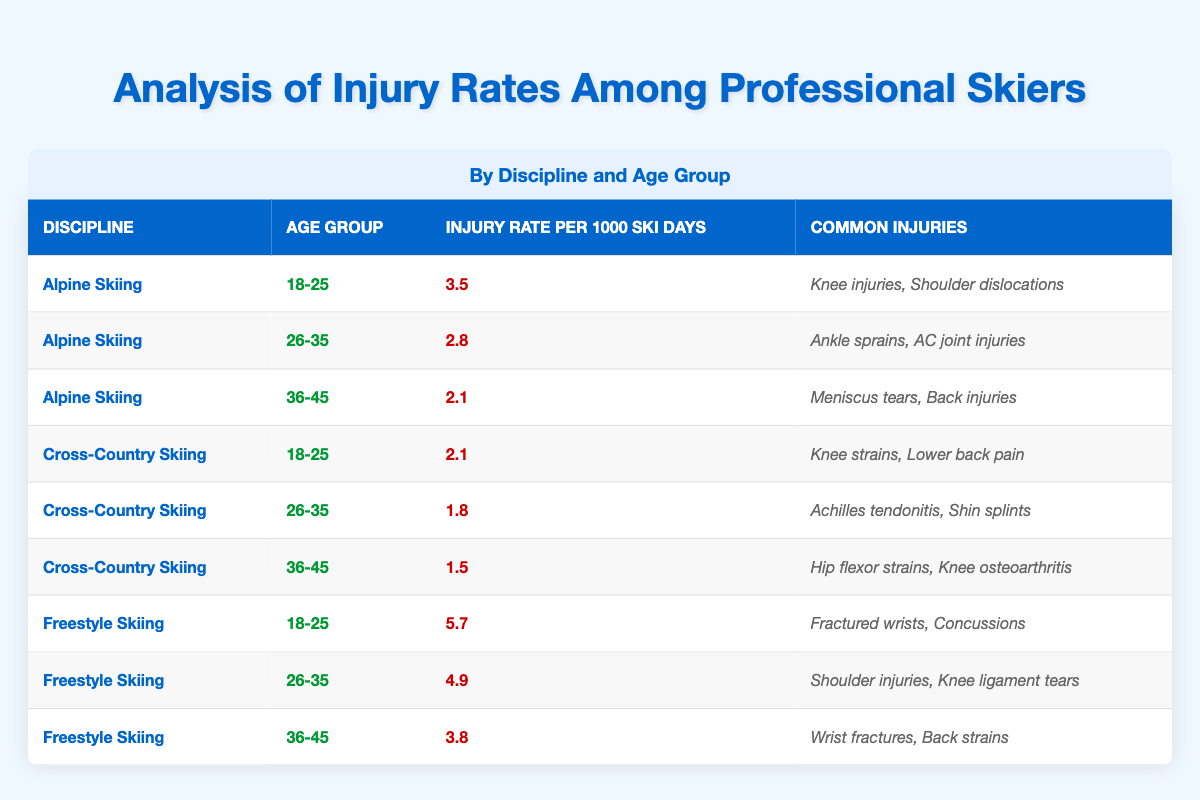What is the average injury rate for Alpine Skiing in the age group 26-35? The table indicates that for the discipline of Alpine Skiing in the age group of 26-35, the average injury rate per 1000 ski days is 2.8.
Answer: 2.8 What are the common injuries for skiers aged 18-25 in Freestyle Skiing? Looking at the row corresponding to Freestyle Skiing and the age group 18-25, the common injuries listed are fractured wrists and concussions.
Answer: Fractured wrists, concussions Which discipline has the highest average injury rate for skiers aged 36-45? By comparing the average injury rates for the discipline of Alpine Skiing (2.1), Cross-Country Skiing (1.5), and Freestyle Skiing (3.8), it is clear that Freestyle Skiing has the highest average rate for the age group 36-45.
Answer: Freestyle Skiing Is it true that Cross-Country Skiing has a higher injury rate than Alpine Skiing for skiers aged 18-25? Checking the table, Cross-Country Skiing has an average injury rate of 2.1 compared to Alpine Skiing's 3.5 for the same age group. Therefore, the statement is false.
Answer: No What is the difference in average injury rates between the age groups 26-35 and 36-45 for Freestyle Skiing? The table shows that the average injury rate for Freestyle Skiing in the age group 26-35 is 4.9 and for 36-45 is 3.8. The difference can be calculated as 4.9 - 3.8, which equals 1.1.
Answer: 1.1 